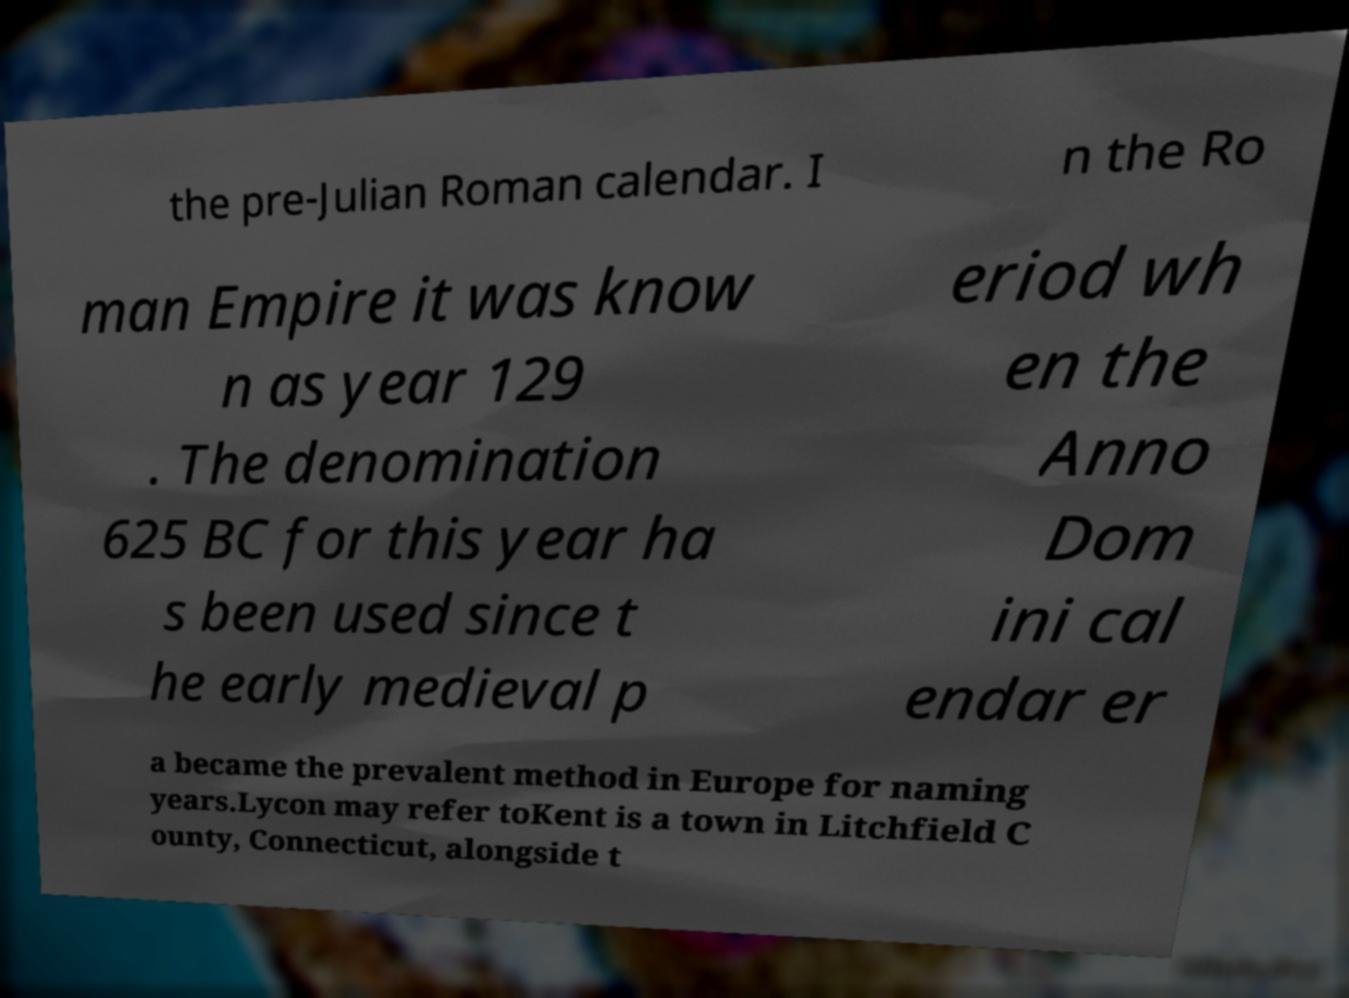For documentation purposes, I need the text within this image transcribed. Could you provide that? the pre-Julian Roman calendar. I n the Ro man Empire it was know n as year 129 . The denomination 625 BC for this year ha s been used since t he early medieval p eriod wh en the Anno Dom ini cal endar er a became the prevalent method in Europe for naming years.Lycon may refer toKent is a town in Litchfield C ounty, Connecticut, alongside t 